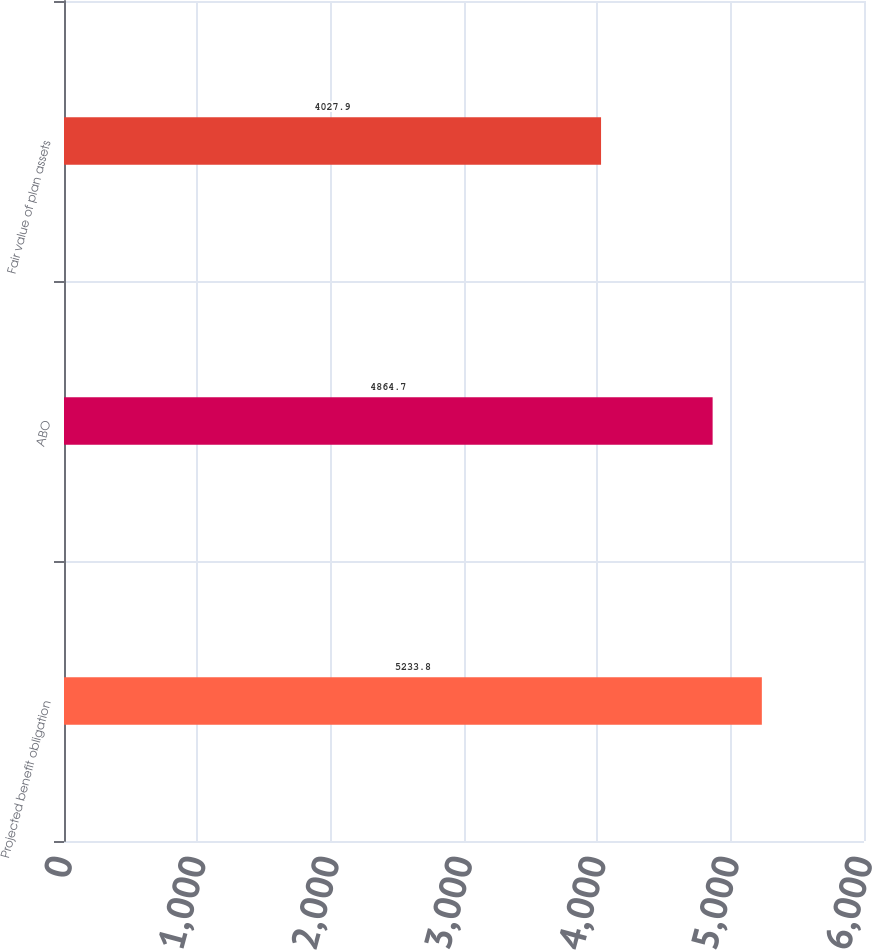Convert chart to OTSL. <chart><loc_0><loc_0><loc_500><loc_500><bar_chart><fcel>Projected benefit obligation<fcel>ABO<fcel>Fair value of plan assets<nl><fcel>5233.8<fcel>4864.7<fcel>4027.9<nl></chart> 